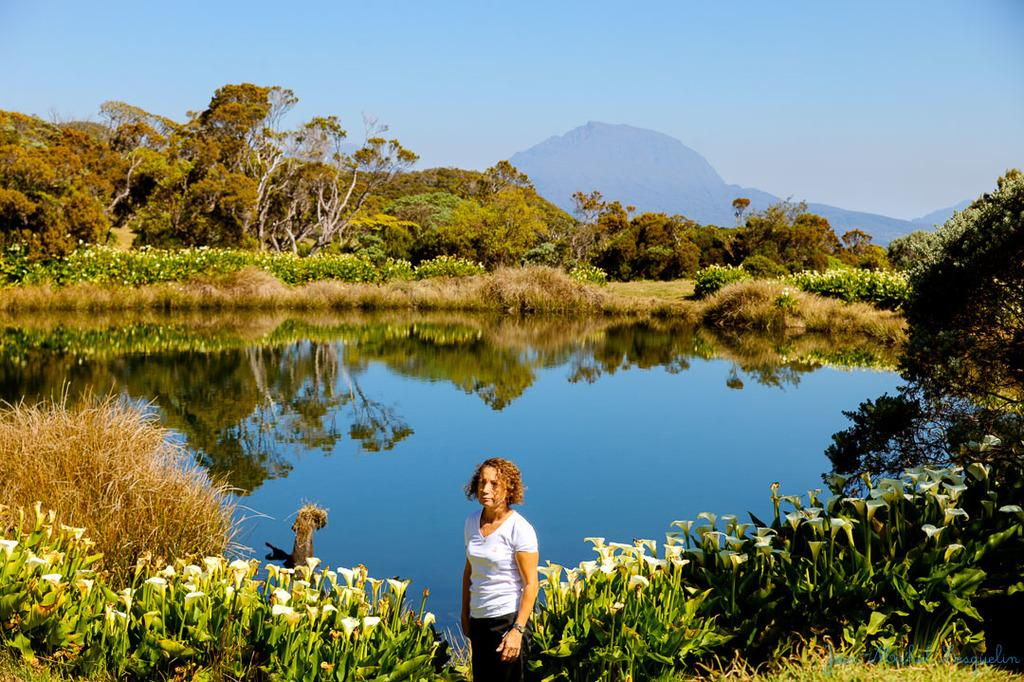Who is present in the image? There is a woman in the image. What is the woman wearing? The woman is wearing a white t-shirt. Where is the woman standing? The woman is standing on a path. What can be seen in the background of the image? There are plants with flowers, water, trees, a hill, and the sky visible in the background. How many geese are swimming in the water in the image? There are no geese present in the image; only plants, water, trees, a hill, and the sky are visible in the background. 